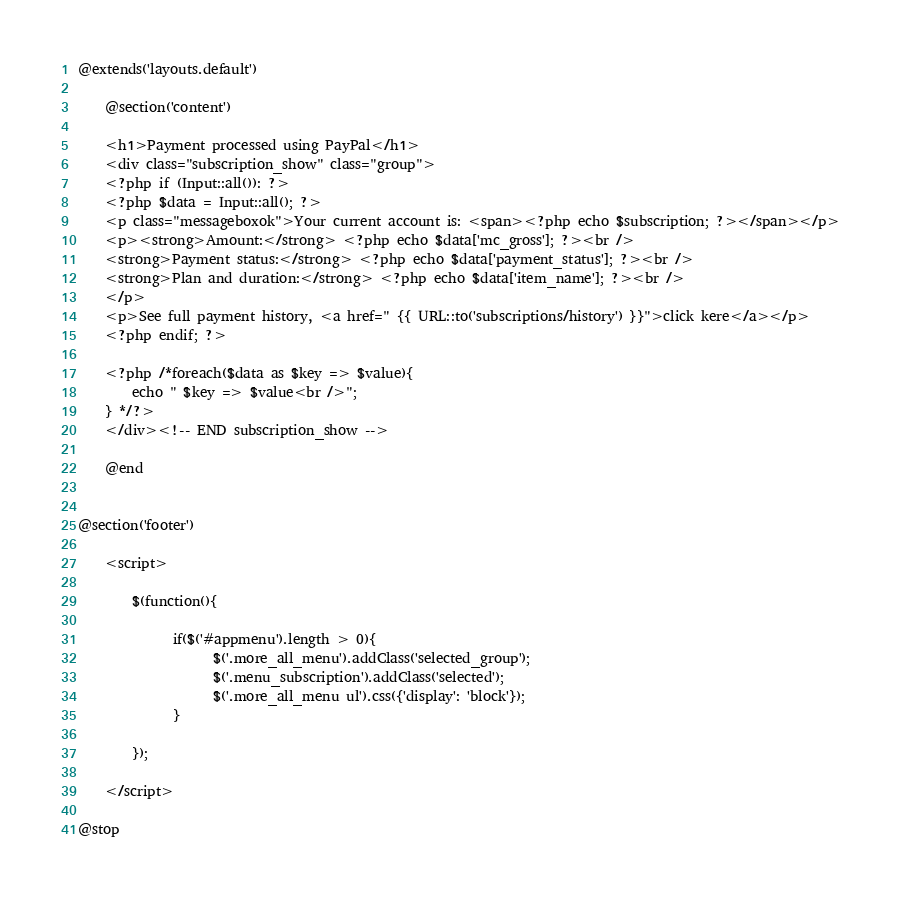Convert code to text. <code><loc_0><loc_0><loc_500><loc_500><_PHP_>@extends('layouts.default')

	@section('content')	 
	
	<h1>Payment processed using PayPal</h1>
	<div class="subscription_show" class="group">
	<?php if (Input::all()): ?>
	<?php $data = Input::all(); ?>
	<p class="messageboxok">Your current account is: <span><?php echo $subscription; ?></span></p>
	<p><strong>Amount:</strong> <?php echo $data['mc_gross']; ?><br />
	<strong>Payment status:</strong> <?php echo $data['payment_status']; ?><br />
	<strong>Plan and duration:</strong> <?php echo $data['item_name']; ?><br />
	</p>
	<p>See full payment history, <a href=" {{ URL::to('subscriptions/history') }}">click kere</a></p>
	<?php endif; ?>
	
	<?php /*foreach($data as $key => $value){
		echo " $key => $value<br />";
	} */?>
	</div><!-- END subscription_show -->
	
	@end
	

@section('footer')

	<script>
	
		$(function(){
		 
		 	  if($('#appmenu').length > 0){
				    $('.more_all_menu').addClass('selected_group'); 		 
			  		$('.menu_subscription').addClass('selected');		  		
			  		$('.more_all_menu ul').css({'display': 'block'});
			  }
		 
		});
		
	</script>
	
@stop</code> 